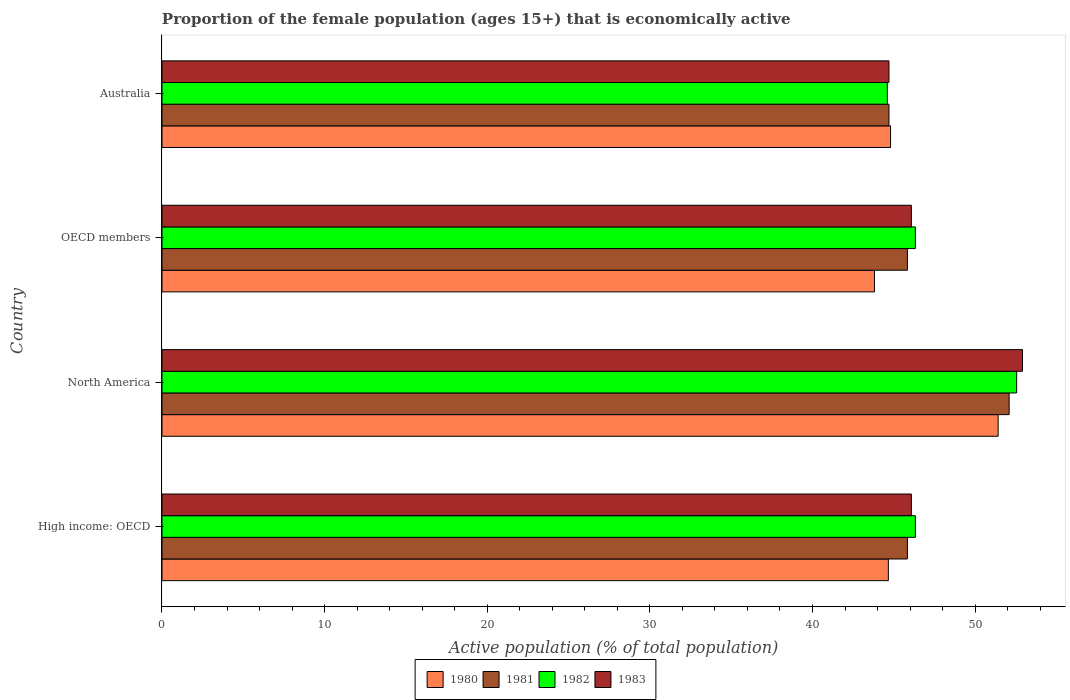How many groups of bars are there?
Ensure brevity in your answer.  4. Are the number of bars per tick equal to the number of legend labels?
Provide a short and direct response. Yes. How many bars are there on the 3rd tick from the bottom?
Provide a short and direct response. 4. What is the label of the 4th group of bars from the top?
Provide a short and direct response. High income: OECD. In how many cases, is the number of bars for a given country not equal to the number of legend labels?
Your answer should be compact. 0. What is the proportion of the female population that is economically active in 1982 in North America?
Your response must be concise. 52.55. Across all countries, what is the maximum proportion of the female population that is economically active in 1983?
Make the answer very short. 52.91. Across all countries, what is the minimum proportion of the female population that is economically active in 1983?
Ensure brevity in your answer.  44.7. In which country was the proportion of the female population that is economically active in 1980 minimum?
Keep it short and to the point. OECD members. What is the total proportion of the female population that is economically active in 1981 in the graph?
Your answer should be compact. 188.46. What is the difference between the proportion of the female population that is economically active in 1981 in Australia and that in North America?
Make the answer very short. -7.39. What is the difference between the proportion of the female population that is economically active in 1981 in Australia and the proportion of the female population that is economically active in 1980 in North America?
Offer a terse response. -6.71. What is the average proportion of the female population that is economically active in 1981 per country?
Your answer should be very brief. 47.12. What is the difference between the proportion of the female population that is economically active in 1981 and proportion of the female population that is economically active in 1980 in North America?
Offer a terse response. 0.68. What is the ratio of the proportion of the female population that is economically active in 1980 in Australia to that in OECD members?
Offer a terse response. 1.02. Is the proportion of the female population that is economically active in 1982 in Australia less than that in North America?
Give a very brief answer. Yes. What is the difference between the highest and the second highest proportion of the female population that is economically active in 1983?
Your answer should be very brief. 6.83. What is the difference between the highest and the lowest proportion of the female population that is economically active in 1982?
Offer a terse response. 7.95. In how many countries, is the proportion of the female population that is economically active in 1983 greater than the average proportion of the female population that is economically active in 1983 taken over all countries?
Keep it short and to the point. 1. What does the 4th bar from the top in North America represents?
Your response must be concise. 1980. What does the 1st bar from the bottom in Australia represents?
Offer a very short reply. 1980. Is it the case that in every country, the sum of the proportion of the female population that is economically active in 1980 and proportion of the female population that is economically active in 1981 is greater than the proportion of the female population that is economically active in 1982?
Provide a succinct answer. Yes. How many bars are there?
Your answer should be compact. 16. Are all the bars in the graph horizontal?
Offer a terse response. Yes. How many countries are there in the graph?
Your answer should be very brief. 4. Does the graph contain any zero values?
Make the answer very short. No. Where does the legend appear in the graph?
Keep it short and to the point. Bottom center. How many legend labels are there?
Your answer should be compact. 4. How are the legend labels stacked?
Ensure brevity in your answer.  Horizontal. What is the title of the graph?
Keep it short and to the point. Proportion of the female population (ages 15+) that is economically active. What is the label or title of the X-axis?
Provide a short and direct response. Active population (% of total population). What is the label or title of the Y-axis?
Your answer should be very brief. Country. What is the Active population (% of total population) of 1980 in High income: OECD?
Your answer should be very brief. 44.66. What is the Active population (% of total population) of 1981 in High income: OECD?
Provide a succinct answer. 45.84. What is the Active population (% of total population) in 1982 in High income: OECD?
Your response must be concise. 46.32. What is the Active population (% of total population) in 1983 in High income: OECD?
Provide a short and direct response. 46.08. What is the Active population (% of total population) in 1980 in North America?
Give a very brief answer. 51.41. What is the Active population (% of total population) in 1981 in North America?
Offer a very short reply. 52.09. What is the Active population (% of total population) of 1982 in North America?
Provide a succinct answer. 52.55. What is the Active population (% of total population) of 1983 in North America?
Offer a terse response. 52.91. What is the Active population (% of total population) in 1980 in OECD members?
Offer a terse response. 43.81. What is the Active population (% of total population) in 1981 in OECD members?
Your answer should be compact. 45.84. What is the Active population (% of total population) of 1982 in OECD members?
Offer a terse response. 46.32. What is the Active population (% of total population) of 1983 in OECD members?
Offer a terse response. 46.08. What is the Active population (% of total population) of 1980 in Australia?
Give a very brief answer. 44.8. What is the Active population (% of total population) of 1981 in Australia?
Your answer should be very brief. 44.7. What is the Active population (% of total population) in 1982 in Australia?
Offer a terse response. 44.6. What is the Active population (% of total population) in 1983 in Australia?
Provide a short and direct response. 44.7. Across all countries, what is the maximum Active population (% of total population) of 1980?
Your response must be concise. 51.41. Across all countries, what is the maximum Active population (% of total population) in 1981?
Your response must be concise. 52.09. Across all countries, what is the maximum Active population (% of total population) in 1982?
Offer a very short reply. 52.55. Across all countries, what is the maximum Active population (% of total population) in 1983?
Your answer should be very brief. 52.91. Across all countries, what is the minimum Active population (% of total population) of 1980?
Ensure brevity in your answer.  43.81. Across all countries, what is the minimum Active population (% of total population) in 1981?
Your response must be concise. 44.7. Across all countries, what is the minimum Active population (% of total population) of 1982?
Offer a very short reply. 44.6. Across all countries, what is the minimum Active population (% of total population) of 1983?
Give a very brief answer. 44.7. What is the total Active population (% of total population) in 1980 in the graph?
Offer a very short reply. 184.69. What is the total Active population (% of total population) of 1981 in the graph?
Ensure brevity in your answer.  188.46. What is the total Active population (% of total population) in 1982 in the graph?
Offer a very short reply. 189.8. What is the total Active population (% of total population) in 1983 in the graph?
Your answer should be very brief. 189.77. What is the difference between the Active population (% of total population) in 1980 in High income: OECD and that in North America?
Make the answer very short. -6.75. What is the difference between the Active population (% of total population) in 1981 in High income: OECD and that in North America?
Ensure brevity in your answer.  -6.25. What is the difference between the Active population (% of total population) in 1982 in High income: OECD and that in North America?
Make the answer very short. -6.23. What is the difference between the Active population (% of total population) in 1983 in High income: OECD and that in North America?
Keep it short and to the point. -6.83. What is the difference between the Active population (% of total population) in 1980 in High income: OECD and that in OECD members?
Your answer should be very brief. 0.85. What is the difference between the Active population (% of total population) in 1980 in High income: OECD and that in Australia?
Offer a very short reply. -0.14. What is the difference between the Active population (% of total population) of 1981 in High income: OECD and that in Australia?
Keep it short and to the point. 1.14. What is the difference between the Active population (% of total population) in 1982 in High income: OECD and that in Australia?
Keep it short and to the point. 1.72. What is the difference between the Active population (% of total population) in 1983 in High income: OECD and that in Australia?
Your answer should be very brief. 1.38. What is the difference between the Active population (% of total population) in 1980 in North America and that in OECD members?
Provide a short and direct response. 7.61. What is the difference between the Active population (% of total population) in 1981 in North America and that in OECD members?
Make the answer very short. 6.25. What is the difference between the Active population (% of total population) of 1982 in North America and that in OECD members?
Keep it short and to the point. 6.23. What is the difference between the Active population (% of total population) of 1983 in North America and that in OECD members?
Offer a terse response. 6.83. What is the difference between the Active population (% of total population) in 1980 in North America and that in Australia?
Your answer should be compact. 6.61. What is the difference between the Active population (% of total population) in 1981 in North America and that in Australia?
Give a very brief answer. 7.39. What is the difference between the Active population (% of total population) in 1982 in North America and that in Australia?
Your response must be concise. 7.95. What is the difference between the Active population (% of total population) of 1983 in North America and that in Australia?
Offer a very short reply. 8.21. What is the difference between the Active population (% of total population) of 1980 in OECD members and that in Australia?
Keep it short and to the point. -0.99. What is the difference between the Active population (% of total population) in 1981 in OECD members and that in Australia?
Make the answer very short. 1.14. What is the difference between the Active population (% of total population) in 1982 in OECD members and that in Australia?
Offer a terse response. 1.72. What is the difference between the Active population (% of total population) of 1983 in OECD members and that in Australia?
Offer a terse response. 1.38. What is the difference between the Active population (% of total population) in 1980 in High income: OECD and the Active population (% of total population) in 1981 in North America?
Keep it short and to the point. -7.43. What is the difference between the Active population (% of total population) of 1980 in High income: OECD and the Active population (% of total population) of 1982 in North America?
Make the answer very short. -7.89. What is the difference between the Active population (% of total population) in 1980 in High income: OECD and the Active population (% of total population) in 1983 in North America?
Your answer should be very brief. -8.25. What is the difference between the Active population (% of total population) of 1981 in High income: OECD and the Active population (% of total population) of 1982 in North America?
Offer a terse response. -6.72. What is the difference between the Active population (% of total population) of 1981 in High income: OECD and the Active population (% of total population) of 1983 in North America?
Make the answer very short. -7.07. What is the difference between the Active population (% of total population) of 1982 in High income: OECD and the Active population (% of total population) of 1983 in North America?
Your answer should be compact. -6.58. What is the difference between the Active population (% of total population) of 1980 in High income: OECD and the Active population (% of total population) of 1981 in OECD members?
Keep it short and to the point. -1.17. What is the difference between the Active population (% of total population) of 1980 in High income: OECD and the Active population (% of total population) of 1982 in OECD members?
Provide a short and direct response. -1.66. What is the difference between the Active population (% of total population) of 1980 in High income: OECD and the Active population (% of total population) of 1983 in OECD members?
Offer a terse response. -1.42. What is the difference between the Active population (% of total population) of 1981 in High income: OECD and the Active population (% of total population) of 1982 in OECD members?
Keep it short and to the point. -0.49. What is the difference between the Active population (% of total population) in 1981 in High income: OECD and the Active population (% of total population) in 1983 in OECD members?
Offer a terse response. -0.24. What is the difference between the Active population (% of total population) of 1982 in High income: OECD and the Active population (% of total population) of 1983 in OECD members?
Make the answer very short. 0.25. What is the difference between the Active population (% of total population) in 1980 in High income: OECD and the Active population (% of total population) in 1981 in Australia?
Ensure brevity in your answer.  -0.04. What is the difference between the Active population (% of total population) of 1980 in High income: OECD and the Active population (% of total population) of 1982 in Australia?
Your answer should be compact. 0.06. What is the difference between the Active population (% of total population) of 1980 in High income: OECD and the Active population (% of total population) of 1983 in Australia?
Give a very brief answer. -0.04. What is the difference between the Active population (% of total population) in 1981 in High income: OECD and the Active population (% of total population) in 1982 in Australia?
Provide a succinct answer. 1.24. What is the difference between the Active population (% of total population) of 1981 in High income: OECD and the Active population (% of total population) of 1983 in Australia?
Make the answer very short. 1.14. What is the difference between the Active population (% of total population) of 1982 in High income: OECD and the Active population (% of total population) of 1983 in Australia?
Ensure brevity in your answer.  1.62. What is the difference between the Active population (% of total population) of 1980 in North America and the Active population (% of total population) of 1981 in OECD members?
Keep it short and to the point. 5.58. What is the difference between the Active population (% of total population) of 1980 in North America and the Active population (% of total population) of 1982 in OECD members?
Make the answer very short. 5.09. What is the difference between the Active population (% of total population) of 1980 in North America and the Active population (% of total population) of 1983 in OECD members?
Your answer should be very brief. 5.34. What is the difference between the Active population (% of total population) in 1981 in North America and the Active population (% of total population) in 1982 in OECD members?
Your answer should be compact. 5.77. What is the difference between the Active population (% of total population) of 1981 in North America and the Active population (% of total population) of 1983 in OECD members?
Your response must be concise. 6.01. What is the difference between the Active population (% of total population) in 1982 in North America and the Active population (% of total population) in 1983 in OECD members?
Provide a short and direct response. 6.47. What is the difference between the Active population (% of total population) of 1980 in North America and the Active population (% of total population) of 1981 in Australia?
Offer a very short reply. 6.71. What is the difference between the Active population (% of total population) in 1980 in North America and the Active population (% of total population) in 1982 in Australia?
Your answer should be very brief. 6.81. What is the difference between the Active population (% of total population) in 1980 in North America and the Active population (% of total population) in 1983 in Australia?
Provide a succinct answer. 6.71. What is the difference between the Active population (% of total population) in 1981 in North America and the Active population (% of total population) in 1982 in Australia?
Your response must be concise. 7.49. What is the difference between the Active population (% of total population) in 1981 in North America and the Active population (% of total population) in 1983 in Australia?
Offer a terse response. 7.39. What is the difference between the Active population (% of total population) of 1982 in North America and the Active population (% of total population) of 1983 in Australia?
Ensure brevity in your answer.  7.85. What is the difference between the Active population (% of total population) in 1980 in OECD members and the Active population (% of total population) in 1981 in Australia?
Give a very brief answer. -0.89. What is the difference between the Active population (% of total population) of 1980 in OECD members and the Active population (% of total population) of 1982 in Australia?
Provide a short and direct response. -0.79. What is the difference between the Active population (% of total population) in 1980 in OECD members and the Active population (% of total population) in 1983 in Australia?
Your answer should be compact. -0.89. What is the difference between the Active population (% of total population) of 1981 in OECD members and the Active population (% of total population) of 1982 in Australia?
Your response must be concise. 1.24. What is the difference between the Active population (% of total population) in 1981 in OECD members and the Active population (% of total population) in 1983 in Australia?
Your response must be concise. 1.14. What is the difference between the Active population (% of total population) in 1982 in OECD members and the Active population (% of total population) in 1983 in Australia?
Provide a succinct answer. 1.62. What is the average Active population (% of total population) of 1980 per country?
Provide a succinct answer. 46.17. What is the average Active population (% of total population) of 1981 per country?
Offer a very short reply. 47.12. What is the average Active population (% of total population) of 1982 per country?
Keep it short and to the point. 47.45. What is the average Active population (% of total population) of 1983 per country?
Your answer should be very brief. 47.44. What is the difference between the Active population (% of total population) in 1980 and Active population (% of total population) in 1981 in High income: OECD?
Ensure brevity in your answer.  -1.17. What is the difference between the Active population (% of total population) of 1980 and Active population (% of total population) of 1982 in High income: OECD?
Make the answer very short. -1.66. What is the difference between the Active population (% of total population) of 1980 and Active population (% of total population) of 1983 in High income: OECD?
Give a very brief answer. -1.42. What is the difference between the Active population (% of total population) of 1981 and Active population (% of total population) of 1982 in High income: OECD?
Keep it short and to the point. -0.49. What is the difference between the Active population (% of total population) in 1981 and Active population (% of total population) in 1983 in High income: OECD?
Your answer should be compact. -0.24. What is the difference between the Active population (% of total population) of 1982 and Active population (% of total population) of 1983 in High income: OECD?
Offer a terse response. 0.25. What is the difference between the Active population (% of total population) of 1980 and Active population (% of total population) of 1981 in North America?
Your answer should be compact. -0.68. What is the difference between the Active population (% of total population) in 1980 and Active population (% of total population) in 1982 in North America?
Provide a succinct answer. -1.14. What is the difference between the Active population (% of total population) in 1980 and Active population (% of total population) in 1983 in North America?
Ensure brevity in your answer.  -1.5. What is the difference between the Active population (% of total population) in 1981 and Active population (% of total population) in 1982 in North America?
Keep it short and to the point. -0.46. What is the difference between the Active population (% of total population) of 1981 and Active population (% of total population) of 1983 in North America?
Offer a very short reply. -0.82. What is the difference between the Active population (% of total population) in 1982 and Active population (% of total population) in 1983 in North America?
Provide a short and direct response. -0.36. What is the difference between the Active population (% of total population) of 1980 and Active population (% of total population) of 1981 in OECD members?
Your response must be concise. -2.03. What is the difference between the Active population (% of total population) of 1980 and Active population (% of total population) of 1982 in OECD members?
Keep it short and to the point. -2.52. What is the difference between the Active population (% of total population) of 1980 and Active population (% of total population) of 1983 in OECD members?
Ensure brevity in your answer.  -2.27. What is the difference between the Active population (% of total population) of 1981 and Active population (% of total population) of 1982 in OECD members?
Your answer should be very brief. -0.49. What is the difference between the Active population (% of total population) of 1981 and Active population (% of total population) of 1983 in OECD members?
Your answer should be compact. -0.24. What is the difference between the Active population (% of total population) in 1982 and Active population (% of total population) in 1983 in OECD members?
Your answer should be very brief. 0.25. What is the difference between the Active population (% of total population) of 1980 and Active population (% of total population) of 1982 in Australia?
Offer a terse response. 0.2. What is the difference between the Active population (% of total population) in 1981 and Active population (% of total population) in 1982 in Australia?
Your answer should be very brief. 0.1. What is the ratio of the Active population (% of total population) in 1980 in High income: OECD to that in North America?
Your answer should be compact. 0.87. What is the ratio of the Active population (% of total population) in 1981 in High income: OECD to that in North America?
Your response must be concise. 0.88. What is the ratio of the Active population (% of total population) in 1982 in High income: OECD to that in North America?
Give a very brief answer. 0.88. What is the ratio of the Active population (% of total population) in 1983 in High income: OECD to that in North America?
Offer a terse response. 0.87. What is the ratio of the Active population (% of total population) in 1980 in High income: OECD to that in OECD members?
Offer a terse response. 1.02. What is the ratio of the Active population (% of total population) of 1982 in High income: OECD to that in OECD members?
Your answer should be compact. 1. What is the ratio of the Active population (% of total population) of 1983 in High income: OECD to that in OECD members?
Provide a succinct answer. 1. What is the ratio of the Active population (% of total population) of 1980 in High income: OECD to that in Australia?
Your response must be concise. 1. What is the ratio of the Active population (% of total population) of 1981 in High income: OECD to that in Australia?
Give a very brief answer. 1.03. What is the ratio of the Active population (% of total population) of 1982 in High income: OECD to that in Australia?
Offer a very short reply. 1.04. What is the ratio of the Active population (% of total population) of 1983 in High income: OECD to that in Australia?
Your answer should be very brief. 1.03. What is the ratio of the Active population (% of total population) of 1980 in North America to that in OECD members?
Provide a succinct answer. 1.17. What is the ratio of the Active population (% of total population) in 1981 in North America to that in OECD members?
Your answer should be very brief. 1.14. What is the ratio of the Active population (% of total population) in 1982 in North America to that in OECD members?
Offer a very short reply. 1.13. What is the ratio of the Active population (% of total population) of 1983 in North America to that in OECD members?
Offer a very short reply. 1.15. What is the ratio of the Active population (% of total population) in 1980 in North America to that in Australia?
Provide a succinct answer. 1.15. What is the ratio of the Active population (% of total population) in 1981 in North America to that in Australia?
Give a very brief answer. 1.17. What is the ratio of the Active population (% of total population) in 1982 in North America to that in Australia?
Your response must be concise. 1.18. What is the ratio of the Active population (% of total population) in 1983 in North America to that in Australia?
Make the answer very short. 1.18. What is the ratio of the Active population (% of total population) in 1980 in OECD members to that in Australia?
Your response must be concise. 0.98. What is the ratio of the Active population (% of total population) in 1981 in OECD members to that in Australia?
Your answer should be compact. 1.03. What is the ratio of the Active population (% of total population) in 1982 in OECD members to that in Australia?
Give a very brief answer. 1.04. What is the ratio of the Active population (% of total population) of 1983 in OECD members to that in Australia?
Offer a terse response. 1.03. What is the difference between the highest and the second highest Active population (% of total population) in 1980?
Your answer should be compact. 6.61. What is the difference between the highest and the second highest Active population (% of total population) of 1981?
Your response must be concise. 6.25. What is the difference between the highest and the second highest Active population (% of total population) of 1982?
Ensure brevity in your answer.  6.23. What is the difference between the highest and the second highest Active population (% of total population) of 1983?
Provide a succinct answer. 6.83. What is the difference between the highest and the lowest Active population (% of total population) of 1980?
Offer a very short reply. 7.61. What is the difference between the highest and the lowest Active population (% of total population) of 1981?
Make the answer very short. 7.39. What is the difference between the highest and the lowest Active population (% of total population) in 1982?
Make the answer very short. 7.95. What is the difference between the highest and the lowest Active population (% of total population) of 1983?
Provide a short and direct response. 8.21. 